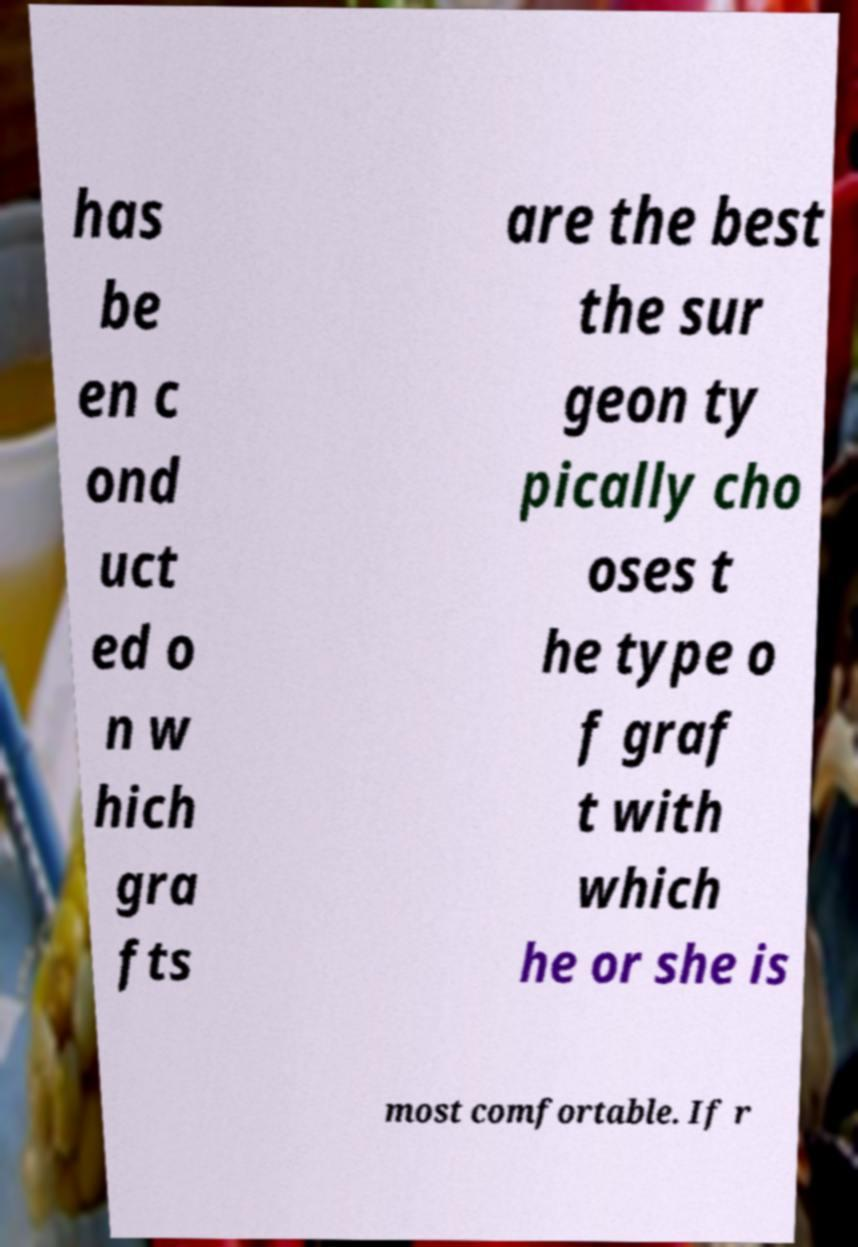Can you read and provide the text displayed in the image?This photo seems to have some interesting text. Can you extract and type it out for me? has be en c ond uct ed o n w hich gra fts are the best the sur geon ty pically cho oses t he type o f graf t with which he or she is most comfortable. If r 